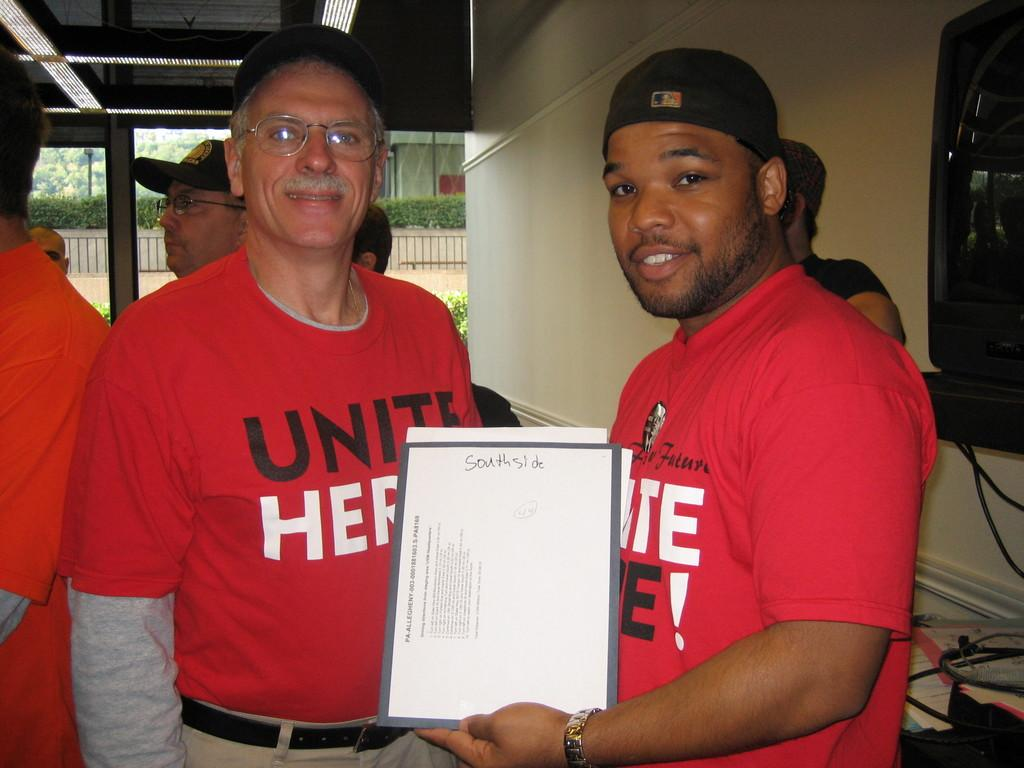<image>
Share a concise interpretation of the image provided. A man in a red shirt holds up a paper that has the words south side on the top. 